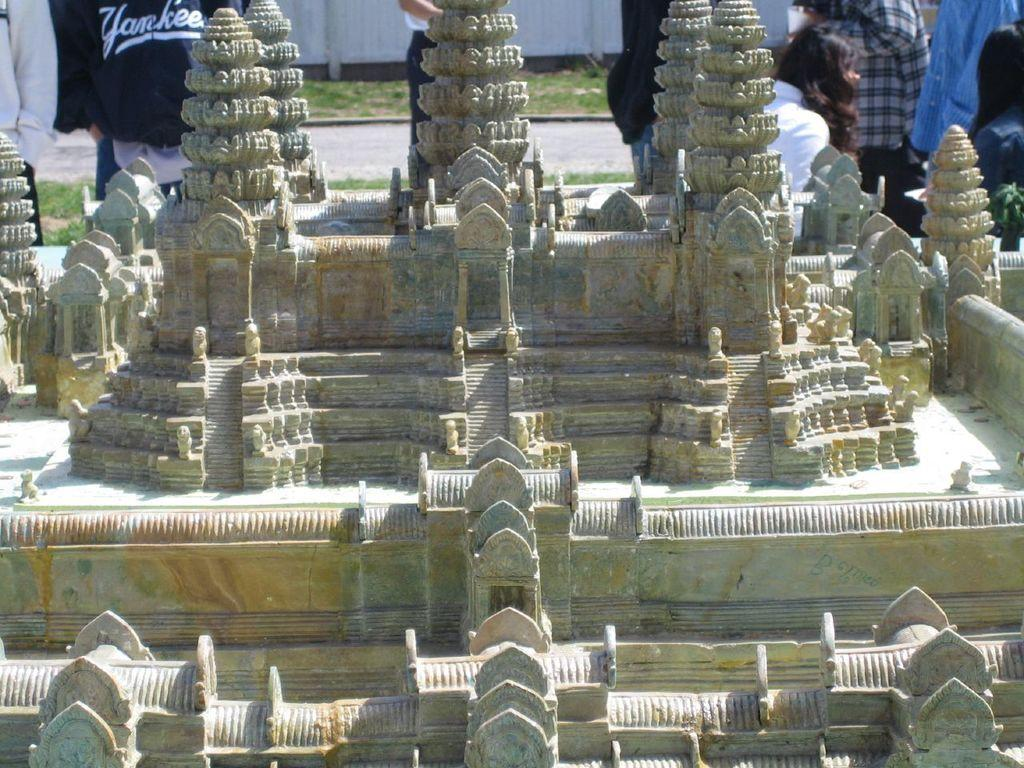What is the main subject of the image? There is a model of a monument in the image. Can you describe the people in the image? There are people behind the model. What type of terrain is visible in the image? There is grassy land visible in the image. What type of nail is being used to hold the model together in the image? There is no nail visible in the image, and the model's construction is not mentioned in the provided facts. Can you tell me how many planes are flying in the background of the image? There are no planes visible in the image; it only features a model of a monument, people, and grassy land. 